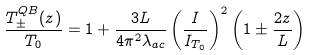Convert formula to latex. <formula><loc_0><loc_0><loc_500><loc_500>\frac { T _ { \pm } ^ { Q B } ( z ) } { T _ { 0 } } = 1 + \frac { 3 L } { 4 \pi ^ { 2 } \lambda _ { a c } } \left ( \frac { I } { I _ { T _ { 0 } } } \right ) ^ { 2 } \left ( 1 \pm \frac { 2 z } { L } \right )</formula> 